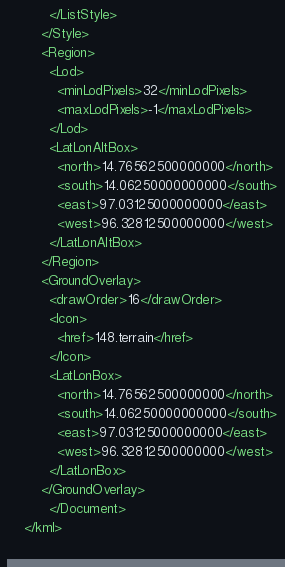Convert code to text. <code><loc_0><loc_0><loc_500><loc_500><_XML_>	      </ListStyle>
	    </Style>
	    <Region>
	      <Lod>
	        <minLodPixels>32</minLodPixels>
	        <maxLodPixels>-1</maxLodPixels>
	      </Lod>
	      <LatLonAltBox>
	        <north>14.76562500000000</north>
	        <south>14.06250000000000</south>
	        <east>97.03125000000000</east>
	        <west>96.32812500000000</west>
	      </LatLonAltBox>
	    </Region>
	    <GroundOverlay>
	      <drawOrder>16</drawOrder>
	      <Icon>
	        <href>148.terrain</href>
	      </Icon>
	      <LatLonBox>
	        <north>14.76562500000000</north>
	        <south>14.06250000000000</south>
	        <east>97.03125000000000</east>
	        <west>96.32812500000000</west>
	      </LatLonBox>
	    </GroundOverlay>
		  </Document>
	</kml>
	</code> 